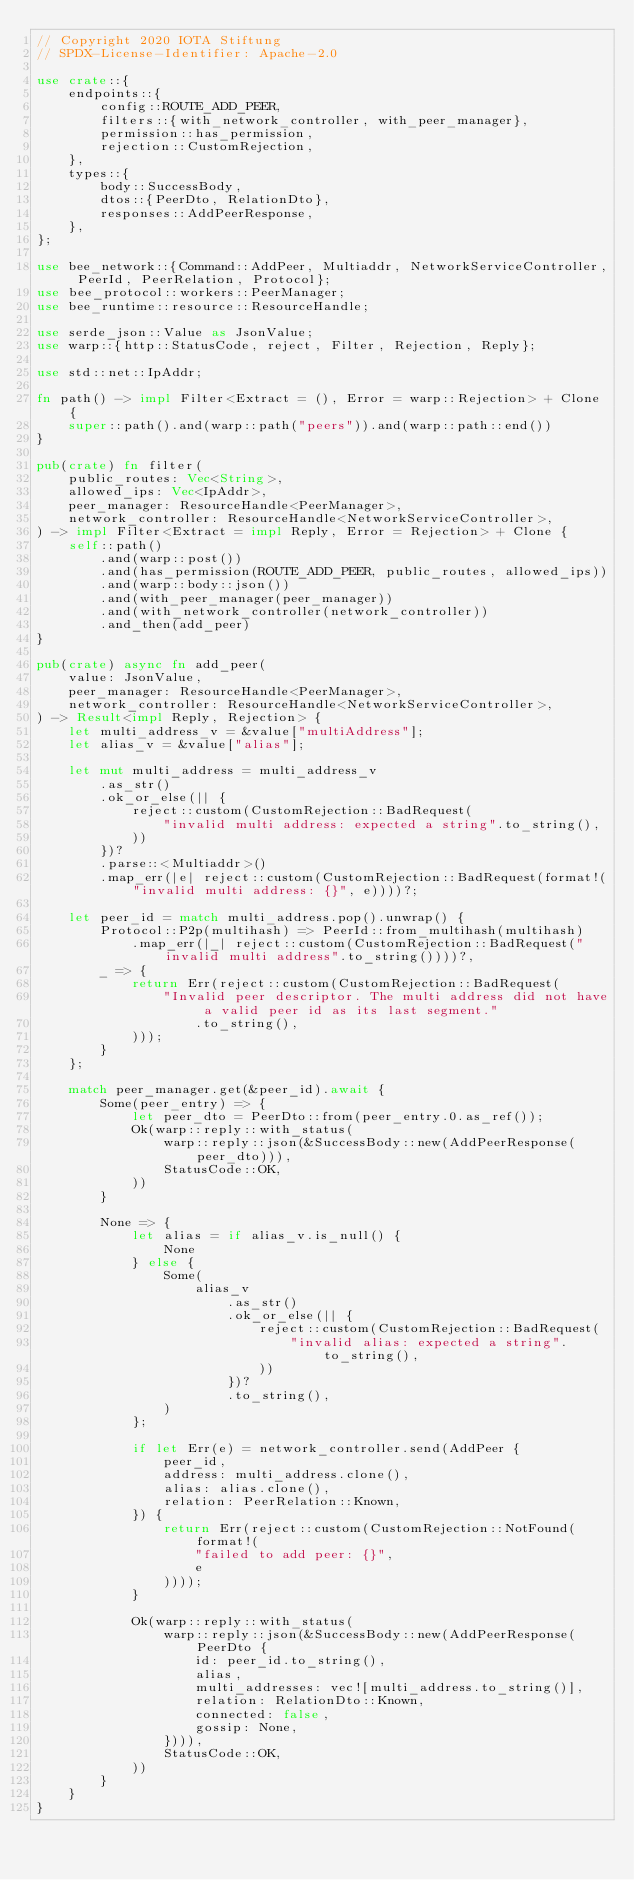Convert code to text. <code><loc_0><loc_0><loc_500><loc_500><_Rust_>// Copyright 2020 IOTA Stiftung
// SPDX-License-Identifier: Apache-2.0

use crate::{
    endpoints::{
        config::ROUTE_ADD_PEER,
        filters::{with_network_controller, with_peer_manager},
        permission::has_permission,
        rejection::CustomRejection,
    },
    types::{
        body::SuccessBody,
        dtos::{PeerDto, RelationDto},
        responses::AddPeerResponse,
    },
};

use bee_network::{Command::AddPeer, Multiaddr, NetworkServiceController, PeerId, PeerRelation, Protocol};
use bee_protocol::workers::PeerManager;
use bee_runtime::resource::ResourceHandle;

use serde_json::Value as JsonValue;
use warp::{http::StatusCode, reject, Filter, Rejection, Reply};

use std::net::IpAddr;

fn path() -> impl Filter<Extract = (), Error = warp::Rejection> + Clone {
    super::path().and(warp::path("peers")).and(warp::path::end())
}

pub(crate) fn filter(
    public_routes: Vec<String>,
    allowed_ips: Vec<IpAddr>,
    peer_manager: ResourceHandle<PeerManager>,
    network_controller: ResourceHandle<NetworkServiceController>,
) -> impl Filter<Extract = impl Reply, Error = Rejection> + Clone {
    self::path()
        .and(warp::post())
        .and(has_permission(ROUTE_ADD_PEER, public_routes, allowed_ips))
        .and(warp::body::json())
        .and(with_peer_manager(peer_manager))
        .and(with_network_controller(network_controller))
        .and_then(add_peer)
}

pub(crate) async fn add_peer(
    value: JsonValue,
    peer_manager: ResourceHandle<PeerManager>,
    network_controller: ResourceHandle<NetworkServiceController>,
) -> Result<impl Reply, Rejection> {
    let multi_address_v = &value["multiAddress"];
    let alias_v = &value["alias"];

    let mut multi_address = multi_address_v
        .as_str()
        .ok_or_else(|| {
            reject::custom(CustomRejection::BadRequest(
                "invalid multi address: expected a string".to_string(),
            ))
        })?
        .parse::<Multiaddr>()
        .map_err(|e| reject::custom(CustomRejection::BadRequest(format!("invalid multi address: {}", e))))?;

    let peer_id = match multi_address.pop().unwrap() {
        Protocol::P2p(multihash) => PeerId::from_multihash(multihash)
            .map_err(|_| reject::custom(CustomRejection::BadRequest("invalid multi address".to_string())))?,
        _ => {
            return Err(reject::custom(CustomRejection::BadRequest(
                "Invalid peer descriptor. The multi address did not have a valid peer id as its last segment."
                    .to_string(),
            )));
        }
    };

    match peer_manager.get(&peer_id).await {
        Some(peer_entry) => {
            let peer_dto = PeerDto::from(peer_entry.0.as_ref());
            Ok(warp::reply::with_status(
                warp::reply::json(&SuccessBody::new(AddPeerResponse(peer_dto))),
                StatusCode::OK,
            ))
        }

        None => {
            let alias = if alias_v.is_null() {
                None
            } else {
                Some(
                    alias_v
                        .as_str()
                        .ok_or_else(|| {
                            reject::custom(CustomRejection::BadRequest(
                                "invalid alias: expected a string".to_string(),
                            ))
                        })?
                        .to_string(),
                )
            };

            if let Err(e) = network_controller.send(AddPeer {
                peer_id,
                address: multi_address.clone(),
                alias: alias.clone(),
                relation: PeerRelation::Known,
            }) {
                return Err(reject::custom(CustomRejection::NotFound(format!(
                    "failed to add peer: {}",
                    e
                ))));
            }

            Ok(warp::reply::with_status(
                warp::reply::json(&SuccessBody::new(AddPeerResponse(PeerDto {
                    id: peer_id.to_string(),
                    alias,
                    multi_addresses: vec![multi_address.to_string()],
                    relation: RelationDto::Known,
                    connected: false,
                    gossip: None,
                }))),
                StatusCode::OK,
            ))
        }
    }
}
</code> 